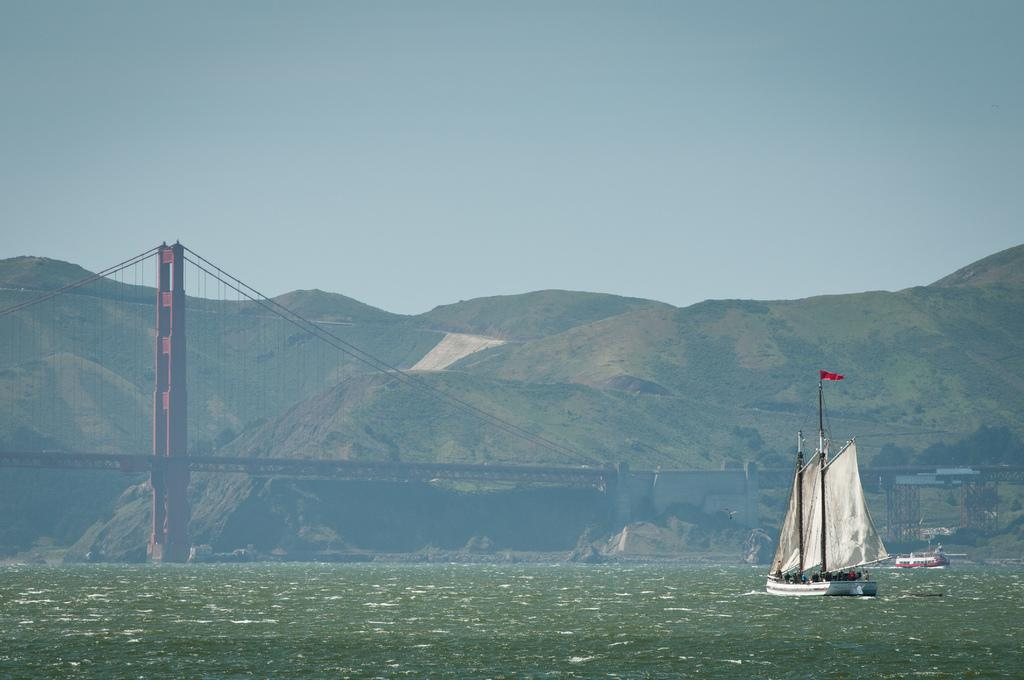What type of vehicles can be seen in the water in the image? There are boats in the water in the image. What structure is visible in the image that connects two areas? There is a bridge visible in the image. What type of landform can be seen in the image? There are hills in the image. What is visible above the land and water in the image? The sky is visible in the image. Can you tell me what book the boats are reading in the image? There are no books or reading activities depicted in the image; it features boats in the water, a bridge, hills, and the sky. Is there a skateboarder performing tricks on the bridge in the image? There is no skateboarder or any indication of skateboarding in the image; it only shows boats, a bridge, hills, and the sky. 